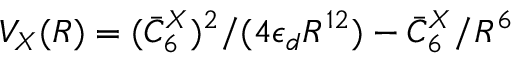Convert formula to latex. <formula><loc_0><loc_0><loc_500><loc_500>V _ { X } ( R ) = ( \bar { C } _ { 6 } ^ { X } ) ^ { 2 } / ( 4 \epsilon _ { d } R ^ { 1 2 } ) - \bar { C } _ { 6 } ^ { X } / R ^ { 6 }</formula> 